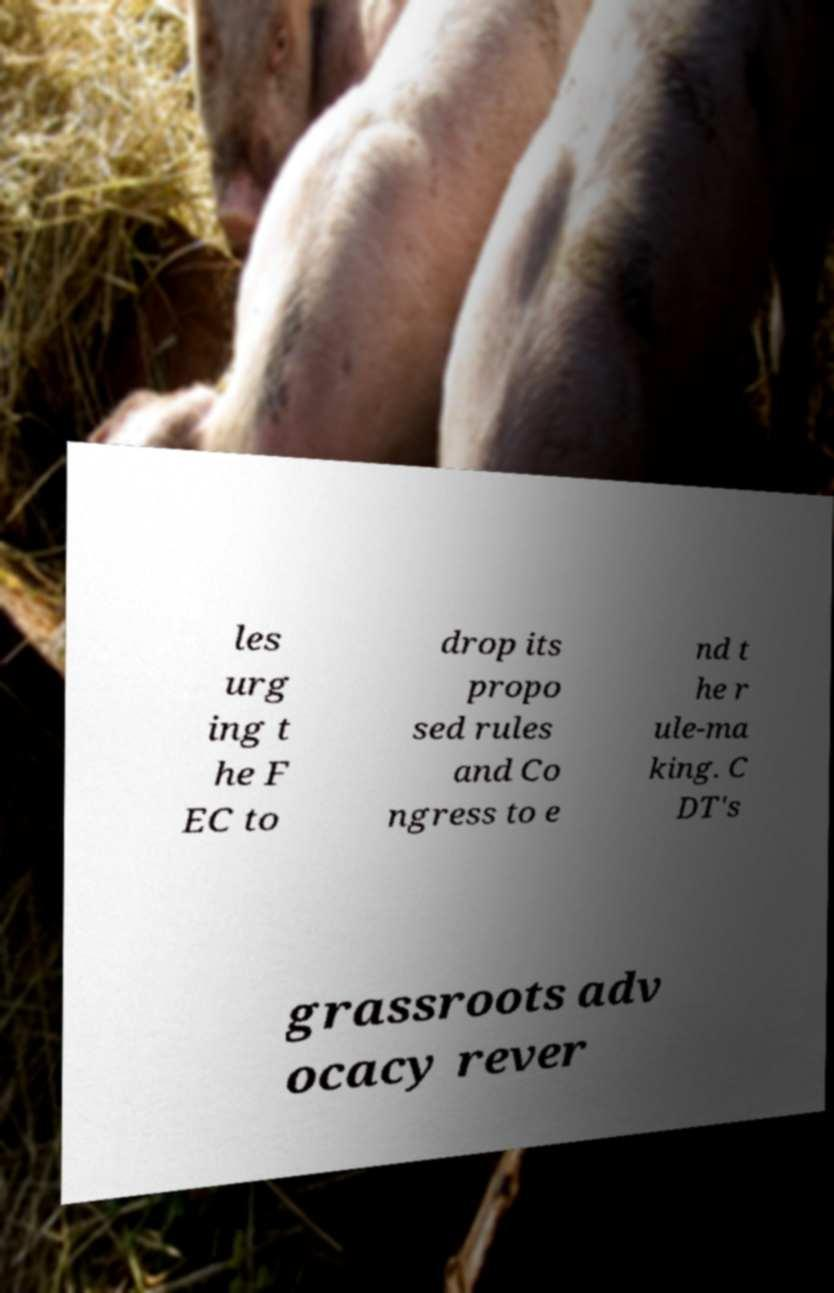Can you read and provide the text displayed in the image?This photo seems to have some interesting text. Can you extract and type it out for me? les urg ing t he F EC to drop its propo sed rules and Co ngress to e nd t he r ule-ma king. C DT's grassroots adv ocacy rever 